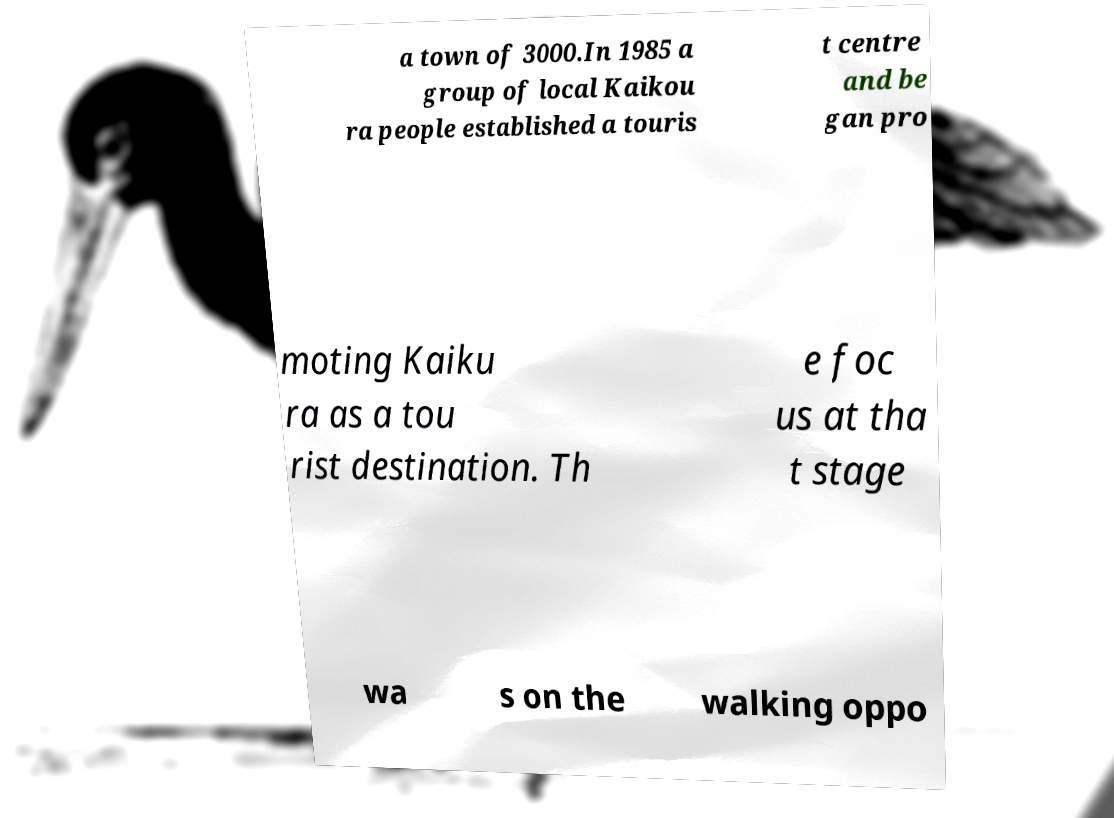For documentation purposes, I need the text within this image transcribed. Could you provide that? a town of 3000.In 1985 a group of local Kaikou ra people established a touris t centre and be gan pro moting Kaiku ra as a tou rist destination. Th e foc us at tha t stage wa s on the walking oppo 